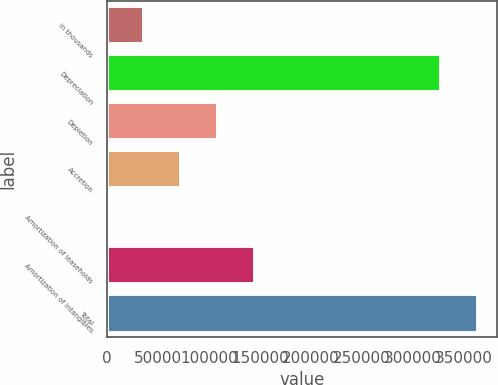Convert chart. <chart><loc_0><loc_0><loc_500><loc_500><bar_chart><fcel>in thousands<fcel>Depreciation<fcel>Depletion<fcel>Accretion<fcel>Amortization of leaseholds<fcel>Amortization of intangibles<fcel>Total<nl><fcel>36374.4<fcel>328072<fcel>108673<fcel>72523.8<fcel>225<fcel>144823<fcel>364221<nl></chart> 